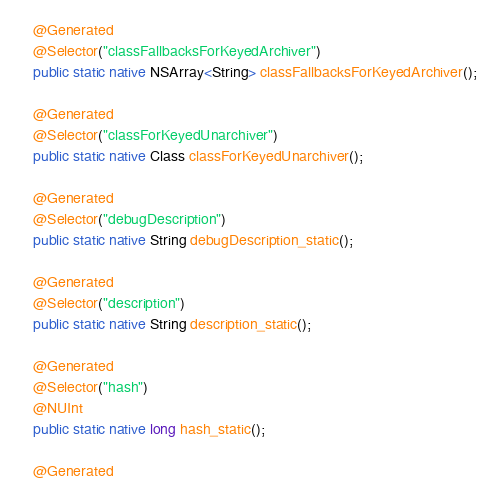Convert code to text. <code><loc_0><loc_0><loc_500><loc_500><_Java_>
    @Generated
    @Selector("classFallbacksForKeyedArchiver")
    public static native NSArray<String> classFallbacksForKeyedArchiver();

    @Generated
    @Selector("classForKeyedUnarchiver")
    public static native Class classForKeyedUnarchiver();

    @Generated
    @Selector("debugDescription")
    public static native String debugDescription_static();

    @Generated
    @Selector("description")
    public static native String description_static();

    @Generated
    @Selector("hash")
    @NUInt
    public static native long hash_static();

    @Generated</code> 